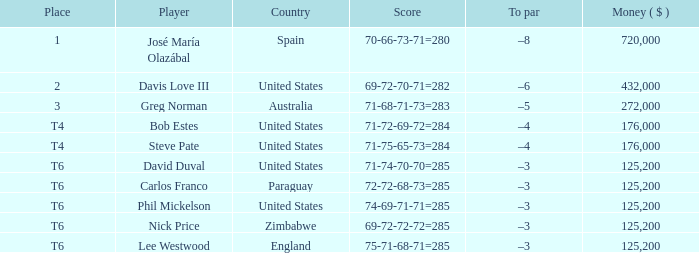Which score holds a t6 ranking and represents paraguay? 72-72-68-73=285. 